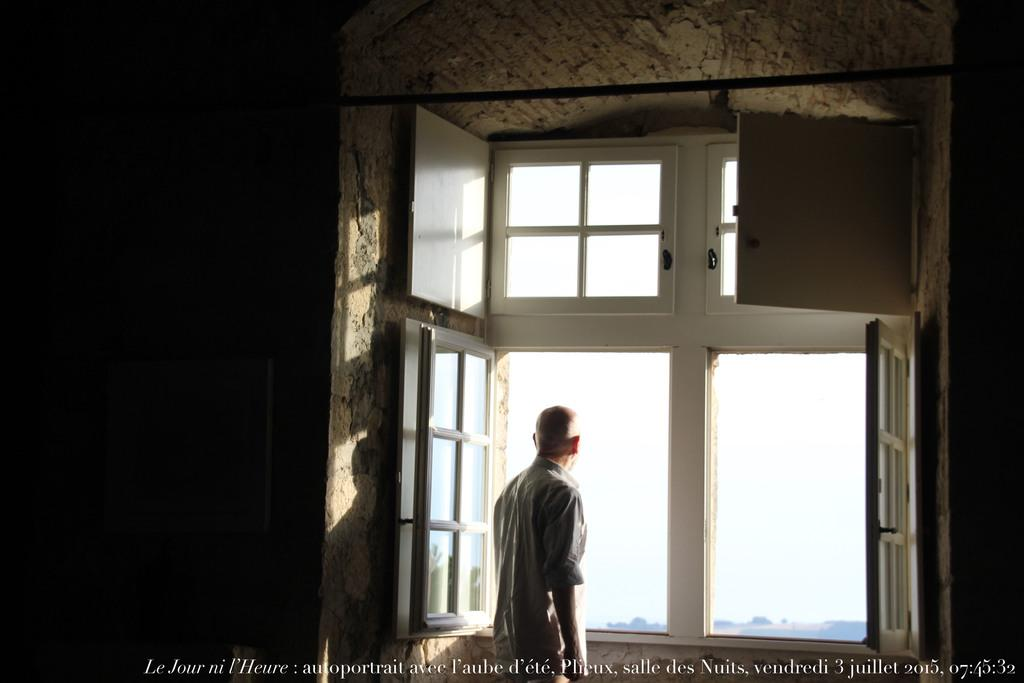What is the person in the image doing? The person is standing in front of a window. What can be seen above the person in the image? There is a pole above the person. Is there any text or information provided below the image? Yes, there is something written below the image. What type of locket is the person wearing around their neck in the image? There is no locket visible around the person's neck in the image. Is the person wearing a mask in the image? There is no mask visible on the person in the image. 